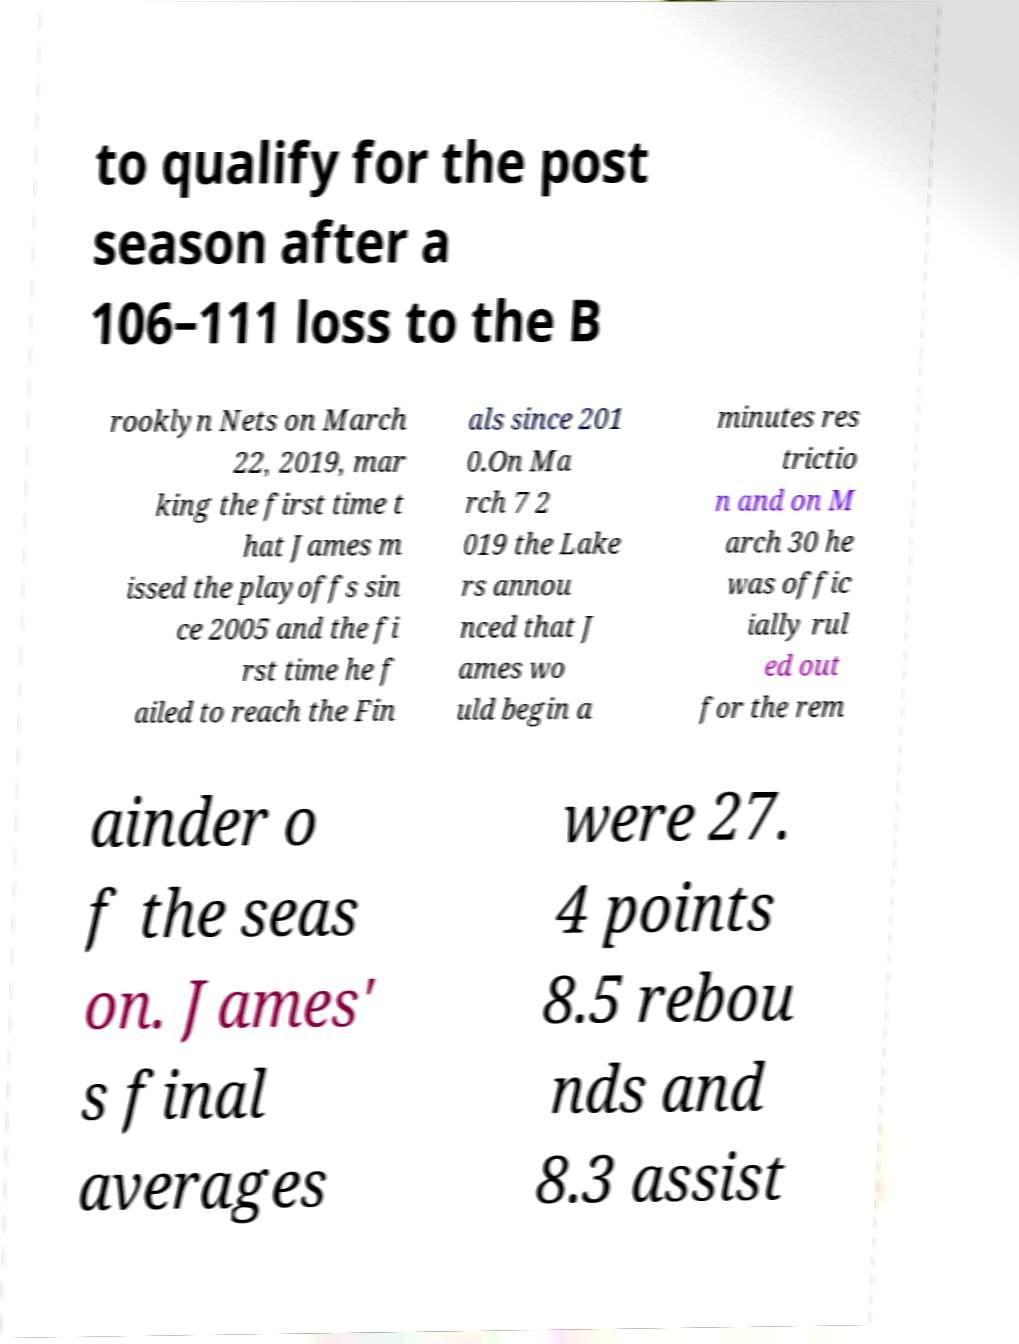I need the written content from this picture converted into text. Can you do that? to qualify for the post season after a 106–111 loss to the B rooklyn Nets on March 22, 2019, mar king the first time t hat James m issed the playoffs sin ce 2005 and the fi rst time he f ailed to reach the Fin als since 201 0.On Ma rch 7 2 019 the Lake rs annou nced that J ames wo uld begin a minutes res trictio n and on M arch 30 he was offic ially rul ed out for the rem ainder o f the seas on. James' s final averages were 27. 4 points 8.5 rebou nds and 8.3 assist 